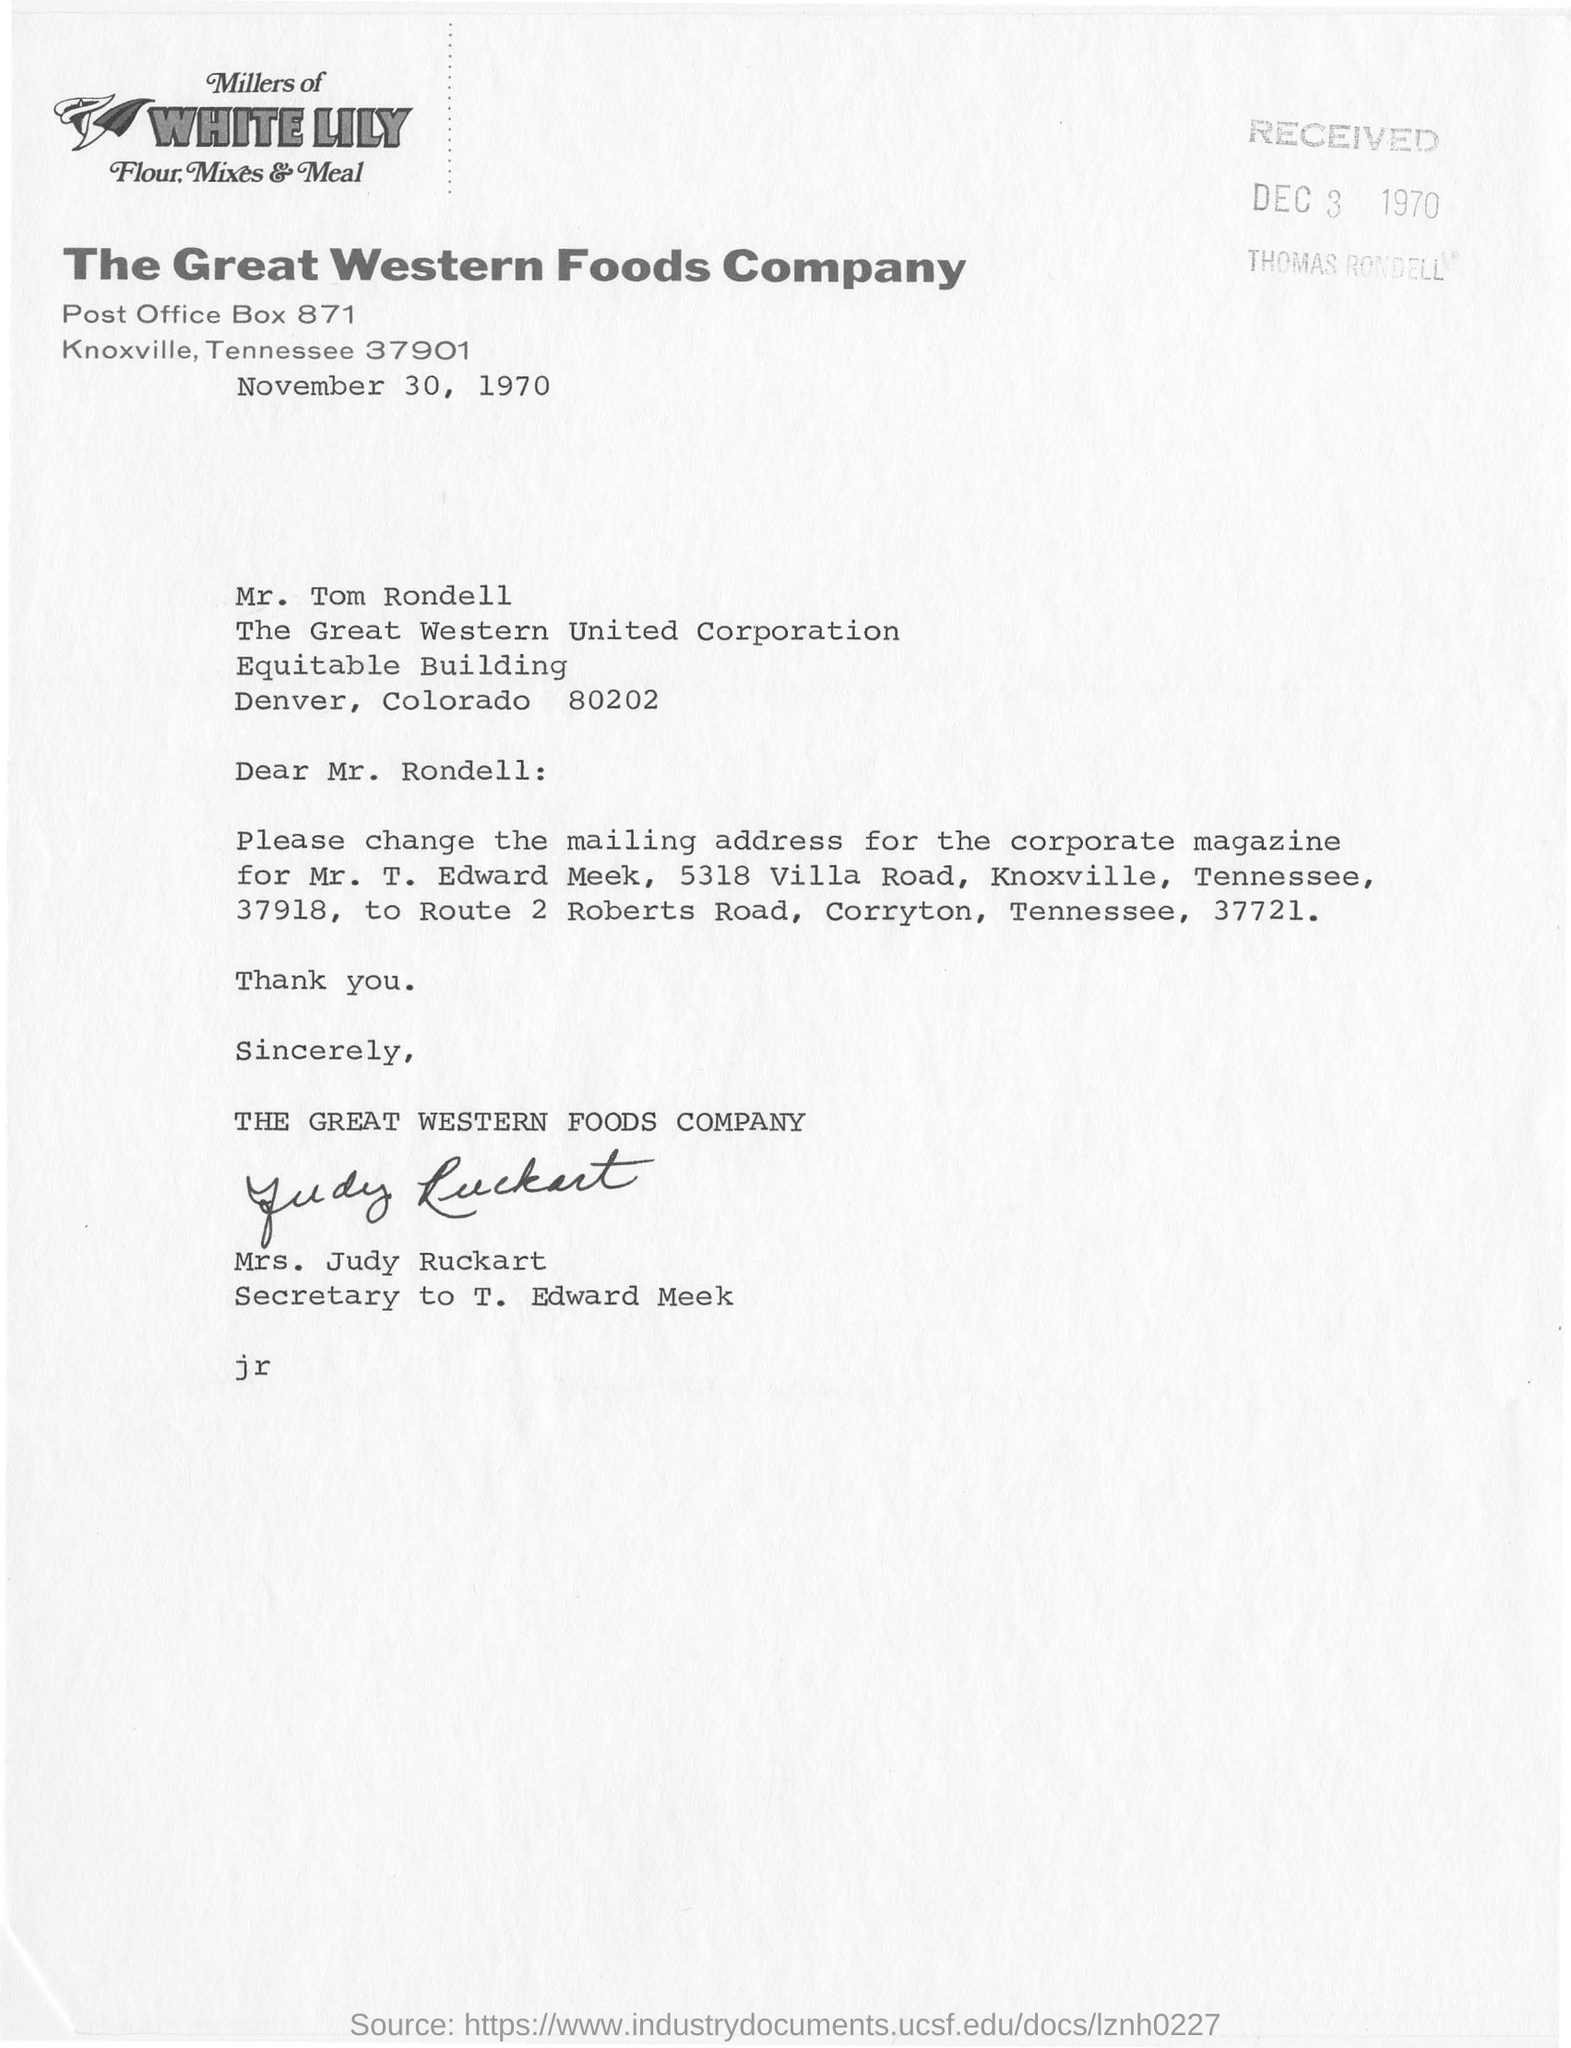When was it received?
Give a very brief answer. Dec 3 1970. What is the name of the company?
Give a very brief answer. The great western foods company. 